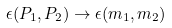<formula> <loc_0><loc_0><loc_500><loc_500>\epsilon ( P _ { 1 } , P _ { 2 } ) \rightarrow \epsilon ( m _ { 1 } , m _ { 2 } )</formula> 